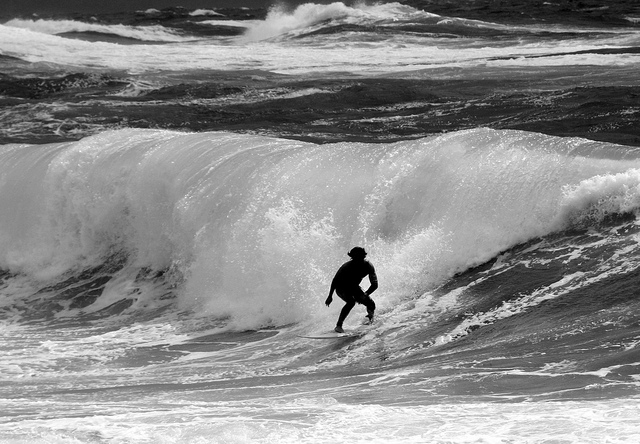What time of day does the lighting suggest? The lighting and shadows suggest that this photo was likely taken in the early morning or late afternoon, where the angle of the sun creates a dramatic contrast between light and dark areas. 